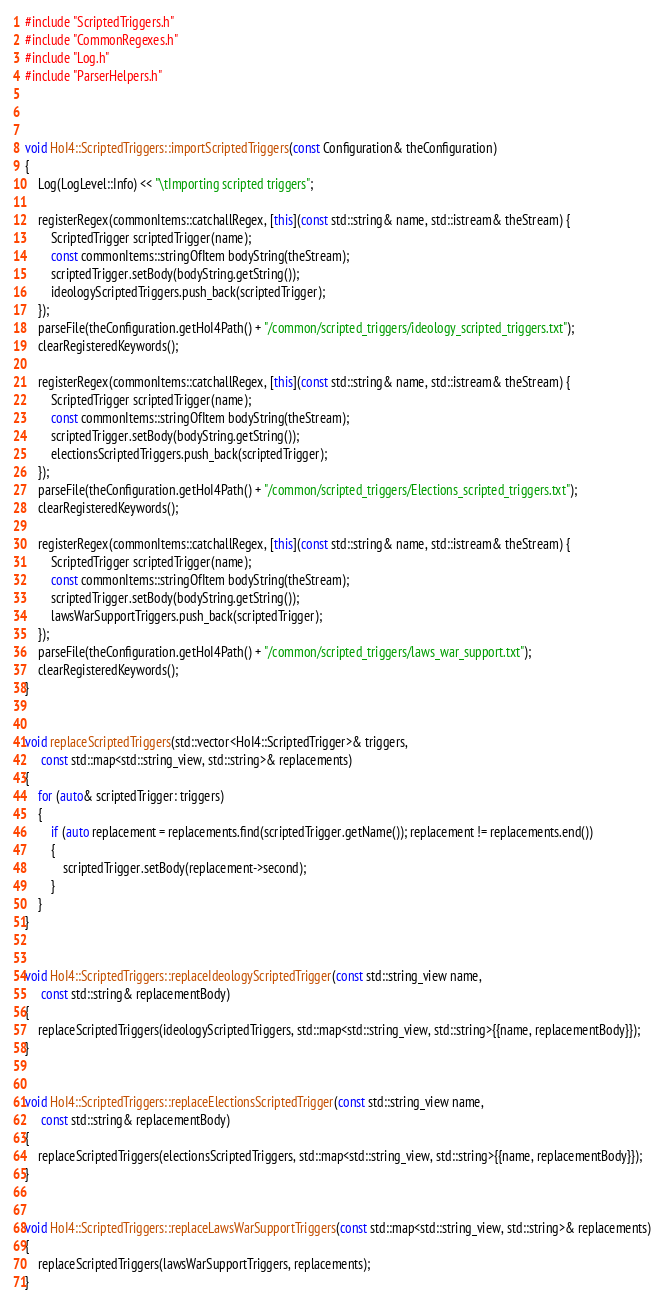<code> <loc_0><loc_0><loc_500><loc_500><_C++_>#include "ScriptedTriggers.h"
#include "CommonRegexes.h"
#include "Log.h"
#include "ParserHelpers.h"



void HoI4::ScriptedTriggers::importScriptedTriggers(const Configuration& theConfiguration)
{
	Log(LogLevel::Info) << "\tImporting scripted triggers";

	registerRegex(commonItems::catchallRegex, [this](const std::string& name, std::istream& theStream) {
		ScriptedTrigger scriptedTrigger(name);
		const commonItems::stringOfItem bodyString(theStream);
		scriptedTrigger.setBody(bodyString.getString());
		ideologyScriptedTriggers.push_back(scriptedTrigger);
	});
	parseFile(theConfiguration.getHoI4Path() + "/common/scripted_triggers/ideology_scripted_triggers.txt");
	clearRegisteredKeywords();

	registerRegex(commonItems::catchallRegex, [this](const std::string& name, std::istream& theStream) {
		ScriptedTrigger scriptedTrigger(name);
		const commonItems::stringOfItem bodyString(theStream);
		scriptedTrigger.setBody(bodyString.getString());
		electionsScriptedTriggers.push_back(scriptedTrigger);
	});
	parseFile(theConfiguration.getHoI4Path() + "/common/scripted_triggers/Elections_scripted_triggers.txt");
	clearRegisteredKeywords();

	registerRegex(commonItems::catchallRegex, [this](const std::string& name, std::istream& theStream) {
		ScriptedTrigger scriptedTrigger(name);
		const commonItems::stringOfItem bodyString(theStream);
		scriptedTrigger.setBody(bodyString.getString());
		lawsWarSupportTriggers.push_back(scriptedTrigger);
	});
	parseFile(theConfiguration.getHoI4Path() + "/common/scripted_triggers/laws_war_support.txt");
	clearRegisteredKeywords();
}


void replaceScriptedTriggers(std::vector<HoI4::ScriptedTrigger>& triggers,
	 const std::map<std::string_view, std::string>& replacements)
{
	for (auto& scriptedTrigger: triggers)
	{
		if (auto replacement = replacements.find(scriptedTrigger.getName()); replacement != replacements.end())
		{
			scriptedTrigger.setBody(replacement->second);
		}
	}
}


void HoI4::ScriptedTriggers::replaceIdeologyScriptedTrigger(const std::string_view name,
	 const std::string& replacementBody)
{
	replaceScriptedTriggers(ideologyScriptedTriggers, std::map<std::string_view, std::string>{{name, replacementBody}});
}


void HoI4::ScriptedTriggers::replaceElectionsScriptedTrigger(const std::string_view name,
	 const std::string& replacementBody)
{
	replaceScriptedTriggers(electionsScriptedTriggers, std::map<std::string_view, std::string>{{name, replacementBody}});
}


void HoI4::ScriptedTriggers::replaceLawsWarSupportTriggers(const std::map<std::string_view, std::string>& replacements)
{
	replaceScriptedTriggers(lawsWarSupportTriggers, replacements);
}</code> 